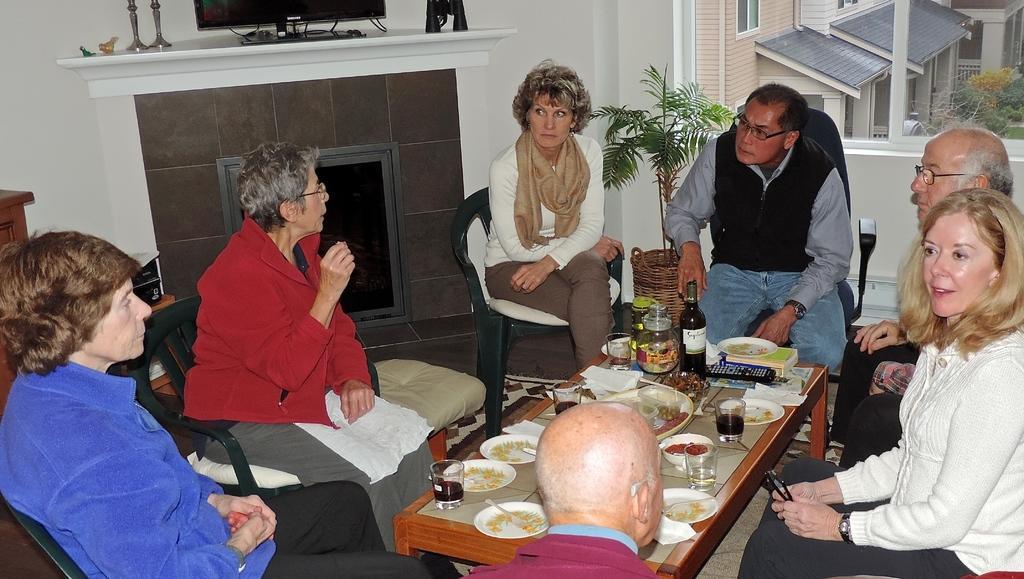Please provide a concise description of this image. Here we can see a group of people sitting on chairs with table in front of them having food on plates, bottles of wine and glasses present and behind them we can see a plant, we can see a window and other buildings present and there is a fire stock present 